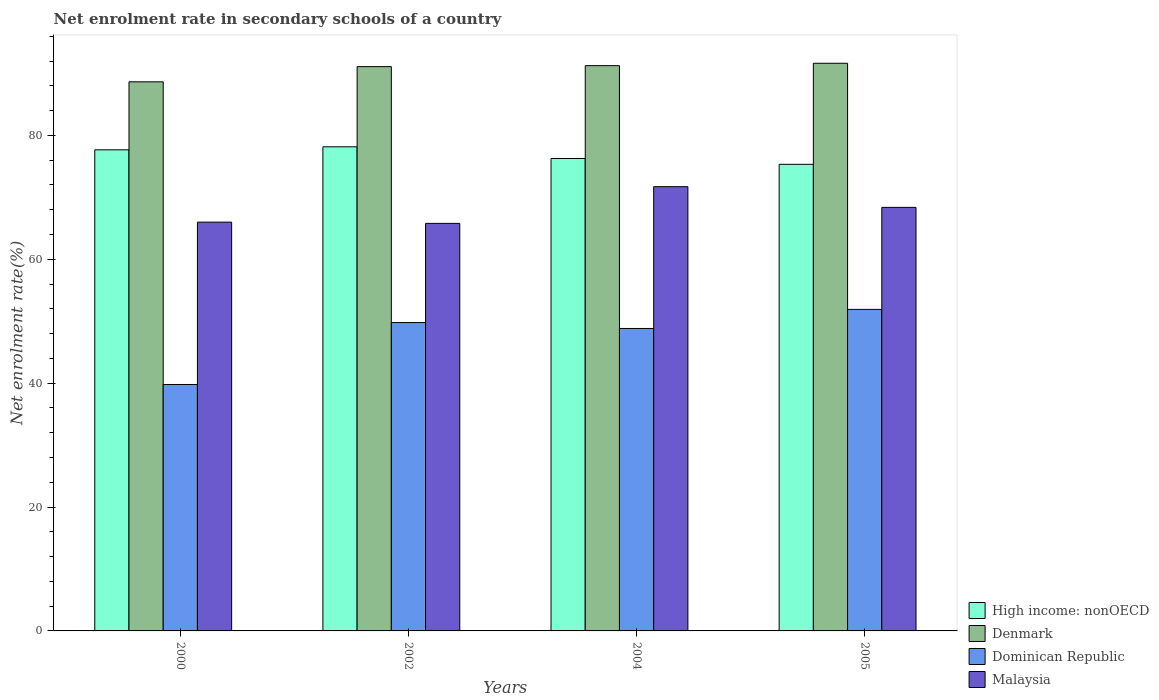Are the number of bars per tick equal to the number of legend labels?
Ensure brevity in your answer.  Yes. Are the number of bars on each tick of the X-axis equal?
Offer a very short reply. Yes. How many bars are there on the 3rd tick from the left?
Provide a short and direct response. 4. How many bars are there on the 3rd tick from the right?
Provide a succinct answer. 4. What is the net enrolment rate in secondary schools in High income: nonOECD in 2002?
Ensure brevity in your answer.  78.16. Across all years, what is the maximum net enrolment rate in secondary schools in High income: nonOECD?
Offer a terse response. 78.16. Across all years, what is the minimum net enrolment rate in secondary schools in Dominican Republic?
Your response must be concise. 39.78. In which year was the net enrolment rate in secondary schools in Denmark maximum?
Make the answer very short. 2005. In which year was the net enrolment rate in secondary schools in Dominican Republic minimum?
Your answer should be very brief. 2000. What is the total net enrolment rate in secondary schools in Malaysia in the graph?
Ensure brevity in your answer.  271.88. What is the difference between the net enrolment rate in secondary schools in Denmark in 2004 and that in 2005?
Provide a short and direct response. -0.39. What is the difference between the net enrolment rate in secondary schools in High income: nonOECD in 2000 and the net enrolment rate in secondary schools in Dominican Republic in 2005?
Your answer should be compact. 25.76. What is the average net enrolment rate in secondary schools in Dominican Republic per year?
Your answer should be very brief. 47.57. In the year 2000, what is the difference between the net enrolment rate in secondary schools in Denmark and net enrolment rate in secondary schools in Dominican Republic?
Keep it short and to the point. 48.86. In how many years, is the net enrolment rate in secondary schools in Denmark greater than 8 %?
Provide a succinct answer. 4. What is the ratio of the net enrolment rate in secondary schools in High income: nonOECD in 2000 to that in 2005?
Provide a short and direct response. 1.03. What is the difference between the highest and the second highest net enrolment rate in secondary schools in Dominican Republic?
Provide a succinct answer. 2.13. What is the difference between the highest and the lowest net enrolment rate in secondary schools in High income: nonOECD?
Make the answer very short. 2.83. In how many years, is the net enrolment rate in secondary schools in Malaysia greater than the average net enrolment rate in secondary schools in Malaysia taken over all years?
Your answer should be compact. 2. Is the sum of the net enrolment rate in secondary schools in High income: nonOECD in 2002 and 2005 greater than the maximum net enrolment rate in secondary schools in Malaysia across all years?
Keep it short and to the point. Yes. What does the 1st bar from the left in 2005 represents?
Keep it short and to the point. High income: nonOECD. Is it the case that in every year, the sum of the net enrolment rate in secondary schools in High income: nonOECD and net enrolment rate in secondary schools in Dominican Republic is greater than the net enrolment rate in secondary schools in Denmark?
Ensure brevity in your answer.  Yes. How many bars are there?
Provide a succinct answer. 16. How many years are there in the graph?
Make the answer very short. 4. Does the graph contain any zero values?
Your response must be concise. No. Does the graph contain grids?
Offer a very short reply. No. Where does the legend appear in the graph?
Ensure brevity in your answer.  Bottom right. How many legend labels are there?
Keep it short and to the point. 4. How are the legend labels stacked?
Keep it short and to the point. Vertical. What is the title of the graph?
Ensure brevity in your answer.  Net enrolment rate in secondary schools of a country. What is the label or title of the Y-axis?
Your answer should be very brief. Net enrolment rate(%). What is the Net enrolment rate(%) in High income: nonOECD in 2000?
Your response must be concise. 77.67. What is the Net enrolment rate(%) of Denmark in 2000?
Keep it short and to the point. 88.65. What is the Net enrolment rate(%) of Dominican Republic in 2000?
Keep it short and to the point. 39.78. What is the Net enrolment rate(%) of Malaysia in 2000?
Provide a short and direct response. 66. What is the Net enrolment rate(%) in High income: nonOECD in 2002?
Your response must be concise. 78.16. What is the Net enrolment rate(%) of Denmark in 2002?
Provide a succinct answer. 91.1. What is the Net enrolment rate(%) of Dominican Republic in 2002?
Make the answer very short. 49.78. What is the Net enrolment rate(%) of Malaysia in 2002?
Your answer should be very brief. 65.79. What is the Net enrolment rate(%) in High income: nonOECD in 2004?
Make the answer very short. 76.27. What is the Net enrolment rate(%) in Denmark in 2004?
Make the answer very short. 91.26. What is the Net enrolment rate(%) in Dominican Republic in 2004?
Offer a very short reply. 48.83. What is the Net enrolment rate(%) in Malaysia in 2004?
Ensure brevity in your answer.  71.72. What is the Net enrolment rate(%) of High income: nonOECD in 2005?
Offer a terse response. 75.33. What is the Net enrolment rate(%) in Denmark in 2005?
Make the answer very short. 91.64. What is the Net enrolment rate(%) of Dominican Republic in 2005?
Offer a terse response. 51.91. What is the Net enrolment rate(%) in Malaysia in 2005?
Ensure brevity in your answer.  68.38. Across all years, what is the maximum Net enrolment rate(%) of High income: nonOECD?
Make the answer very short. 78.16. Across all years, what is the maximum Net enrolment rate(%) of Denmark?
Give a very brief answer. 91.64. Across all years, what is the maximum Net enrolment rate(%) of Dominican Republic?
Offer a very short reply. 51.91. Across all years, what is the maximum Net enrolment rate(%) of Malaysia?
Your response must be concise. 71.72. Across all years, what is the minimum Net enrolment rate(%) of High income: nonOECD?
Offer a terse response. 75.33. Across all years, what is the minimum Net enrolment rate(%) of Denmark?
Your response must be concise. 88.65. Across all years, what is the minimum Net enrolment rate(%) in Dominican Republic?
Ensure brevity in your answer.  39.78. Across all years, what is the minimum Net enrolment rate(%) of Malaysia?
Ensure brevity in your answer.  65.79. What is the total Net enrolment rate(%) in High income: nonOECD in the graph?
Your answer should be very brief. 307.42. What is the total Net enrolment rate(%) in Denmark in the graph?
Offer a terse response. 362.65. What is the total Net enrolment rate(%) in Dominican Republic in the graph?
Provide a succinct answer. 190.3. What is the total Net enrolment rate(%) of Malaysia in the graph?
Provide a succinct answer. 271.88. What is the difference between the Net enrolment rate(%) of High income: nonOECD in 2000 and that in 2002?
Offer a terse response. -0.49. What is the difference between the Net enrolment rate(%) in Denmark in 2000 and that in 2002?
Offer a terse response. -2.45. What is the difference between the Net enrolment rate(%) of Dominican Republic in 2000 and that in 2002?
Make the answer very short. -10. What is the difference between the Net enrolment rate(%) of Malaysia in 2000 and that in 2002?
Your answer should be compact. 0.2. What is the difference between the Net enrolment rate(%) of High income: nonOECD in 2000 and that in 2004?
Ensure brevity in your answer.  1.4. What is the difference between the Net enrolment rate(%) of Denmark in 2000 and that in 2004?
Provide a succinct answer. -2.61. What is the difference between the Net enrolment rate(%) in Dominican Republic in 2000 and that in 2004?
Give a very brief answer. -9.04. What is the difference between the Net enrolment rate(%) of Malaysia in 2000 and that in 2004?
Provide a succinct answer. -5.72. What is the difference between the Net enrolment rate(%) of High income: nonOECD in 2000 and that in 2005?
Ensure brevity in your answer.  2.34. What is the difference between the Net enrolment rate(%) of Denmark in 2000 and that in 2005?
Your response must be concise. -3. What is the difference between the Net enrolment rate(%) of Dominican Republic in 2000 and that in 2005?
Ensure brevity in your answer.  -12.12. What is the difference between the Net enrolment rate(%) of Malaysia in 2000 and that in 2005?
Your response must be concise. -2.38. What is the difference between the Net enrolment rate(%) in High income: nonOECD in 2002 and that in 2004?
Your response must be concise. 1.89. What is the difference between the Net enrolment rate(%) of Denmark in 2002 and that in 2004?
Provide a succinct answer. -0.16. What is the difference between the Net enrolment rate(%) of Dominican Republic in 2002 and that in 2004?
Offer a very short reply. 0.95. What is the difference between the Net enrolment rate(%) of Malaysia in 2002 and that in 2004?
Offer a very short reply. -5.93. What is the difference between the Net enrolment rate(%) of High income: nonOECD in 2002 and that in 2005?
Offer a very short reply. 2.83. What is the difference between the Net enrolment rate(%) in Denmark in 2002 and that in 2005?
Offer a terse response. -0.54. What is the difference between the Net enrolment rate(%) of Dominican Republic in 2002 and that in 2005?
Your answer should be very brief. -2.13. What is the difference between the Net enrolment rate(%) of Malaysia in 2002 and that in 2005?
Provide a short and direct response. -2.58. What is the difference between the Net enrolment rate(%) of High income: nonOECD in 2004 and that in 2005?
Provide a short and direct response. 0.94. What is the difference between the Net enrolment rate(%) of Denmark in 2004 and that in 2005?
Offer a terse response. -0.39. What is the difference between the Net enrolment rate(%) in Dominican Republic in 2004 and that in 2005?
Provide a succinct answer. -3.08. What is the difference between the Net enrolment rate(%) of Malaysia in 2004 and that in 2005?
Your response must be concise. 3.34. What is the difference between the Net enrolment rate(%) of High income: nonOECD in 2000 and the Net enrolment rate(%) of Denmark in 2002?
Your answer should be very brief. -13.43. What is the difference between the Net enrolment rate(%) in High income: nonOECD in 2000 and the Net enrolment rate(%) in Dominican Republic in 2002?
Give a very brief answer. 27.89. What is the difference between the Net enrolment rate(%) of High income: nonOECD in 2000 and the Net enrolment rate(%) of Malaysia in 2002?
Your answer should be compact. 11.88. What is the difference between the Net enrolment rate(%) of Denmark in 2000 and the Net enrolment rate(%) of Dominican Republic in 2002?
Your response must be concise. 38.87. What is the difference between the Net enrolment rate(%) in Denmark in 2000 and the Net enrolment rate(%) in Malaysia in 2002?
Offer a terse response. 22.85. What is the difference between the Net enrolment rate(%) in Dominican Republic in 2000 and the Net enrolment rate(%) in Malaysia in 2002?
Your answer should be very brief. -26.01. What is the difference between the Net enrolment rate(%) in High income: nonOECD in 2000 and the Net enrolment rate(%) in Denmark in 2004?
Ensure brevity in your answer.  -13.59. What is the difference between the Net enrolment rate(%) of High income: nonOECD in 2000 and the Net enrolment rate(%) of Dominican Republic in 2004?
Your answer should be compact. 28.84. What is the difference between the Net enrolment rate(%) in High income: nonOECD in 2000 and the Net enrolment rate(%) in Malaysia in 2004?
Offer a very short reply. 5.95. What is the difference between the Net enrolment rate(%) in Denmark in 2000 and the Net enrolment rate(%) in Dominican Republic in 2004?
Provide a short and direct response. 39.82. What is the difference between the Net enrolment rate(%) in Denmark in 2000 and the Net enrolment rate(%) in Malaysia in 2004?
Your answer should be compact. 16.93. What is the difference between the Net enrolment rate(%) in Dominican Republic in 2000 and the Net enrolment rate(%) in Malaysia in 2004?
Your answer should be very brief. -31.94. What is the difference between the Net enrolment rate(%) of High income: nonOECD in 2000 and the Net enrolment rate(%) of Denmark in 2005?
Provide a short and direct response. -13.98. What is the difference between the Net enrolment rate(%) in High income: nonOECD in 2000 and the Net enrolment rate(%) in Dominican Republic in 2005?
Your response must be concise. 25.76. What is the difference between the Net enrolment rate(%) in High income: nonOECD in 2000 and the Net enrolment rate(%) in Malaysia in 2005?
Keep it short and to the point. 9.29. What is the difference between the Net enrolment rate(%) of Denmark in 2000 and the Net enrolment rate(%) of Dominican Republic in 2005?
Provide a short and direct response. 36.74. What is the difference between the Net enrolment rate(%) of Denmark in 2000 and the Net enrolment rate(%) of Malaysia in 2005?
Make the answer very short. 20.27. What is the difference between the Net enrolment rate(%) of Dominican Republic in 2000 and the Net enrolment rate(%) of Malaysia in 2005?
Keep it short and to the point. -28.59. What is the difference between the Net enrolment rate(%) in High income: nonOECD in 2002 and the Net enrolment rate(%) in Denmark in 2004?
Your answer should be compact. -13.1. What is the difference between the Net enrolment rate(%) in High income: nonOECD in 2002 and the Net enrolment rate(%) in Dominican Republic in 2004?
Make the answer very short. 29.33. What is the difference between the Net enrolment rate(%) of High income: nonOECD in 2002 and the Net enrolment rate(%) of Malaysia in 2004?
Make the answer very short. 6.44. What is the difference between the Net enrolment rate(%) of Denmark in 2002 and the Net enrolment rate(%) of Dominican Republic in 2004?
Offer a very short reply. 42.27. What is the difference between the Net enrolment rate(%) in Denmark in 2002 and the Net enrolment rate(%) in Malaysia in 2004?
Give a very brief answer. 19.38. What is the difference between the Net enrolment rate(%) of Dominican Republic in 2002 and the Net enrolment rate(%) of Malaysia in 2004?
Your response must be concise. -21.94. What is the difference between the Net enrolment rate(%) of High income: nonOECD in 2002 and the Net enrolment rate(%) of Denmark in 2005?
Provide a short and direct response. -13.49. What is the difference between the Net enrolment rate(%) of High income: nonOECD in 2002 and the Net enrolment rate(%) of Dominican Republic in 2005?
Offer a very short reply. 26.25. What is the difference between the Net enrolment rate(%) of High income: nonOECD in 2002 and the Net enrolment rate(%) of Malaysia in 2005?
Provide a short and direct response. 9.78. What is the difference between the Net enrolment rate(%) in Denmark in 2002 and the Net enrolment rate(%) in Dominican Republic in 2005?
Your answer should be very brief. 39.19. What is the difference between the Net enrolment rate(%) of Denmark in 2002 and the Net enrolment rate(%) of Malaysia in 2005?
Provide a succinct answer. 22.73. What is the difference between the Net enrolment rate(%) in Dominican Republic in 2002 and the Net enrolment rate(%) in Malaysia in 2005?
Your answer should be very brief. -18.59. What is the difference between the Net enrolment rate(%) in High income: nonOECD in 2004 and the Net enrolment rate(%) in Denmark in 2005?
Ensure brevity in your answer.  -15.37. What is the difference between the Net enrolment rate(%) in High income: nonOECD in 2004 and the Net enrolment rate(%) in Dominican Republic in 2005?
Provide a succinct answer. 24.36. What is the difference between the Net enrolment rate(%) in High income: nonOECD in 2004 and the Net enrolment rate(%) in Malaysia in 2005?
Provide a short and direct response. 7.89. What is the difference between the Net enrolment rate(%) of Denmark in 2004 and the Net enrolment rate(%) of Dominican Republic in 2005?
Give a very brief answer. 39.35. What is the difference between the Net enrolment rate(%) in Denmark in 2004 and the Net enrolment rate(%) in Malaysia in 2005?
Your response must be concise. 22.88. What is the difference between the Net enrolment rate(%) in Dominican Republic in 2004 and the Net enrolment rate(%) in Malaysia in 2005?
Your answer should be compact. -19.55. What is the average Net enrolment rate(%) of High income: nonOECD per year?
Offer a very short reply. 76.85. What is the average Net enrolment rate(%) in Denmark per year?
Provide a short and direct response. 90.66. What is the average Net enrolment rate(%) of Dominican Republic per year?
Provide a short and direct response. 47.57. What is the average Net enrolment rate(%) in Malaysia per year?
Provide a short and direct response. 67.97. In the year 2000, what is the difference between the Net enrolment rate(%) in High income: nonOECD and Net enrolment rate(%) in Denmark?
Your answer should be very brief. -10.98. In the year 2000, what is the difference between the Net enrolment rate(%) in High income: nonOECD and Net enrolment rate(%) in Dominican Republic?
Offer a very short reply. 37.89. In the year 2000, what is the difference between the Net enrolment rate(%) of High income: nonOECD and Net enrolment rate(%) of Malaysia?
Ensure brevity in your answer.  11.67. In the year 2000, what is the difference between the Net enrolment rate(%) of Denmark and Net enrolment rate(%) of Dominican Republic?
Keep it short and to the point. 48.86. In the year 2000, what is the difference between the Net enrolment rate(%) of Denmark and Net enrolment rate(%) of Malaysia?
Make the answer very short. 22.65. In the year 2000, what is the difference between the Net enrolment rate(%) in Dominican Republic and Net enrolment rate(%) in Malaysia?
Your response must be concise. -26.21. In the year 2002, what is the difference between the Net enrolment rate(%) of High income: nonOECD and Net enrolment rate(%) of Denmark?
Provide a short and direct response. -12.95. In the year 2002, what is the difference between the Net enrolment rate(%) in High income: nonOECD and Net enrolment rate(%) in Dominican Republic?
Make the answer very short. 28.37. In the year 2002, what is the difference between the Net enrolment rate(%) of High income: nonOECD and Net enrolment rate(%) of Malaysia?
Ensure brevity in your answer.  12.36. In the year 2002, what is the difference between the Net enrolment rate(%) in Denmark and Net enrolment rate(%) in Dominican Republic?
Provide a succinct answer. 41.32. In the year 2002, what is the difference between the Net enrolment rate(%) in Denmark and Net enrolment rate(%) in Malaysia?
Offer a very short reply. 25.31. In the year 2002, what is the difference between the Net enrolment rate(%) in Dominican Republic and Net enrolment rate(%) in Malaysia?
Give a very brief answer. -16.01. In the year 2004, what is the difference between the Net enrolment rate(%) in High income: nonOECD and Net enrolment rate(%) in Denmark?
Your answer should be very brief. -14.99. In the year 2004, what is the difference between the Net enrolment rate(%) in High income: nonOECD and Net enrolment rate(%) in Dominican Republic?
Make the answer very short. 27.44. In the year 2004, what is the difference between the Net enrolment rate(%) of High income: nonOECD and Net enrolment rate(%) of Malaysia?
Provide a short and direct response. 4.55. In the year 2004, what is the difference between the Net enrolment rate(%) of Denmark and Net enrolment rate(%) of Dominican Republic?
Provide a short and direct response. 42.43. In the year 2004, what is the difference between the Net enrolment rate(%) of Denmark and Net enrolment rate(%) of Malaysia?
Your response must be concise. 19.54. In the year 2004, what is the difference between the Net enrolment rate(%) of Dominican Republic and Net enrolment rate(%) of Malaysia?
Offer a very short reply. -22.89. In the year 2005, what is the difference between the Net enrolment rate(%) of High income: nonOECD and Net enrolment rate(%) of Denmark?
Ensure brevity in your answer.  -16.32. In the year 2005, what is the difference between the Net enrolment rate(%) of High income: nonOECD and Net enrolment rate(%) of Dominican Republic?
Keep it short and to the point. 23.42. In the year 2005, what is the difference between the Net enrolment rate(%) in High income: nonOECD and Net enrolment rate(%) in Malaysia?
Provide a short and direct response. 6.95. In the year 2005, what is the difference between the Net enrolment rate(%) in Denmark and Net enrolment rate(%) in Dominican Republic?
Your answer should be very brief. 39.74. In the year 2005, what is the difference between the Net enrolment rate(%) in Denmark and Net enrolment rate(%) in Malaysia?
Your response must be concise. 23.27. In the year 2005, what is the difference between the Net enrolment rate(%) in Dominican Republic and Net enrolment rate(%) in Malaysia?
Make the answer very short. -16.47. What is the ratio of the Net enrolment rate(%) in High income: nonOECD in 2000 to that in 2002?
Provide a short and direct response. 0.99. What is the ratio of the Net enrolment rate(%) of Denmark in 2000 to that in 2002?
Offer a terse response. 0.97. What is the ratio of the Net enrolment rate(%) in Dominican Republic in 2000 to that in 2002?
Your response must be concise. 0.8. What is the ratio of the Net enrolment rate(%) of High income: nonOECD in 2000 to that in 2004?
Your response must be concise. 1.02. What is the ratio of the Net enrolment rate(%) in Denmark in 2000 to that in 2004?
Make the answer very short. 0.97. What is the ratio of the Net enrolment rate(%) in Dominican Republic in 2000 to that in 2004?
Offer a terse response. 0.81. What is the ratio of the Net enrolment rate(%) of Malaysia in 2000 to that in 2004?
Provide a short and direct response. 0.92. What is the ratio of the Net enrolment rate(%) in High income: nonOECD in 2000 to that in 2005?
Ensure brevity in your answer.  1.03. What is the ratio of the Net enrolment rate(%) in Denmark in 2000 to that in 2005?
Keep it short and to the point. 0.97. What is the ratio of the Net enrolment rate(%) of Dominican Republic in 2000 to that in 2005?
Your answer should be compact. 0.77. What is the ratio of the Net enrolment rate(%) in Malaysia in 2000 to that in 2005?
Your answer should be very brief. 0.97. What is the ratio of the Net enrolment rate(%) of High income: nonOECD in 2002 to that in 2004?
Provide a short and direct response. 1.02. What is the ratio of the Net enrolment rate(%) in Denmark in 2002 to that in 2004?
Your response must be concise. 1. What is the ratio of the Net enrolment rate(%) in Dominican Republic in 2002 to that in 2004?
Offer a terse response. 1.02. What is the ratio of the Net enrolment rate(%) of Malaysia in 2002 to that in 2004?
Offer a very short reply. 0.92. What is the ratio of the Net enrolment rate(%) of High income: nonOECD in 2002 to that in 2005?
Give a very brief answer. 1.04. What is the ratio of the Net enrolment rate(%) in Denmark in 2002 to that in 2005?
Ensure brevity in your answer.  0.99. What is the ratio of the Net enrolment rate(%) in Dominican Republic in 2002 to that in 2005?
Your answer should be very brief. 0.96. What is the ratio of the Net enrolment rate(%) of Malaysia in 2002 to that in 2005?
Keep it short and to the point. 0.96. What is the ratio of the Net enrolment rate(%) of High income: nonOECD in 2004 to that in 2005?
Give a very brief answer. 1.01. What is the ratio of the Net enrolment rate(%) in Dominican Republic in 2004 to that in 2005?
Your answer should be compact. 0.94. What is the ratio of the Net enrolment rate(%) of Malaysia in 2004 to that in 2005?
Give a very brief answer. 1.05. What is the difference between the highest and the second highest Net enrolment rate(%) in High income: nonOECD?
Provide a short and direct response. 0.49. What is the difference between the highest and the second highest Net enrolment rate(%) in Denmark?
Your response must be concise. 0.39. What is the difference between the highest and the second highest Net enrolment rate(%) of Dominican Republic?
Ensure brevity in your answer.  2.13. What is the difference between the highest and the second highest Net enrolment rate(%) in Malaysia?
Provide a short and direct response. 3.34. What is the difference between the highest and the lowest Net enrolment rate(%) in High income: nonOECD?
Offer a very short reply. 2.83. What is the difference between the highest and the lowest Net enrolment rate(%) in Denmark?
Offer a very short reply. 3. What is the difference between the highest and the lowest Net enrolment rate(%) of Dominican Republic?
Your answer should be compact. 12.12. What is the difference between the highest and the lowest Net enrolment rate(%) of Malaysia?
Offer a terse response. 5.93. 